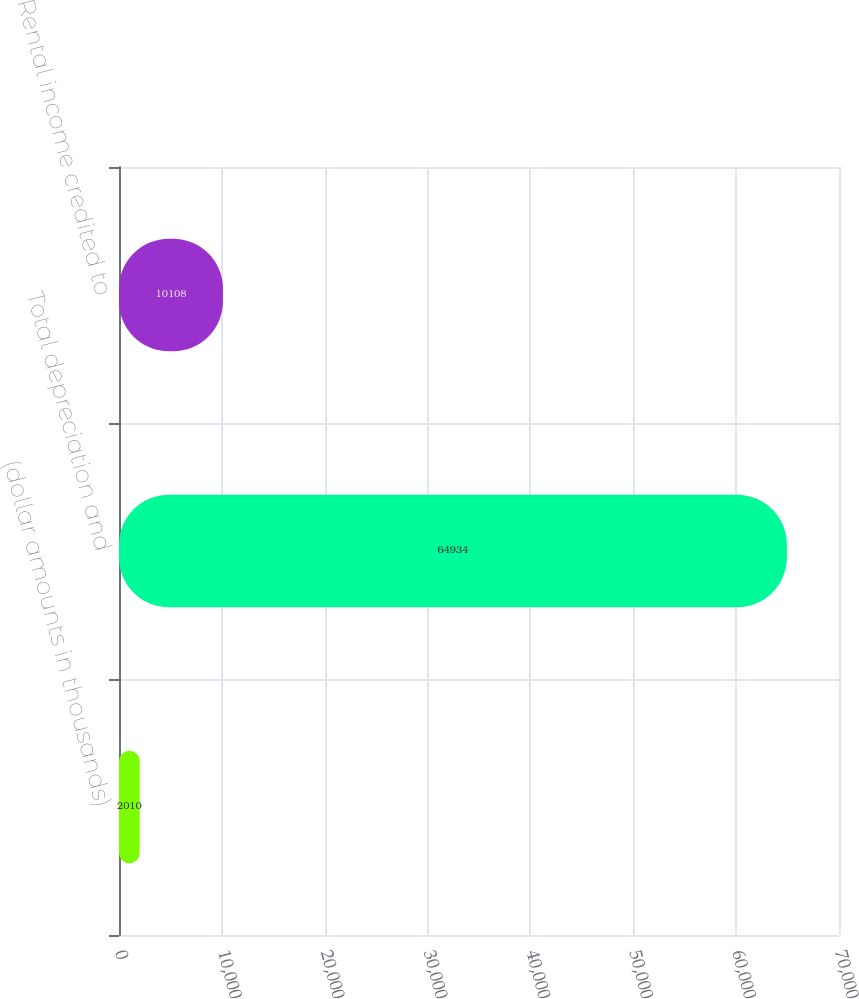Convert chart. <chart><loc_0><loc_0><loc_500><loc_500><bar_chart><fcel>(dollar amounts in thousands)<fcel>Total depreciation and<fcel>Rental income credited to<nl><fcel>2010<fcel>64934<fcel>10108<nl></chart> 